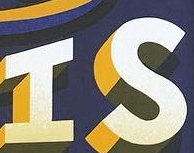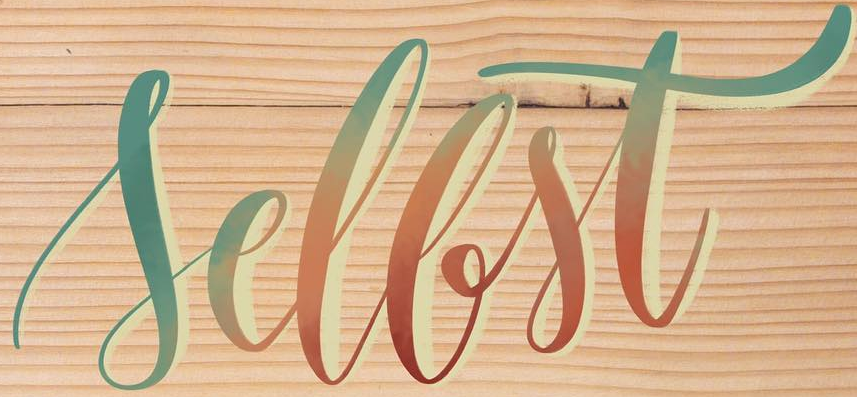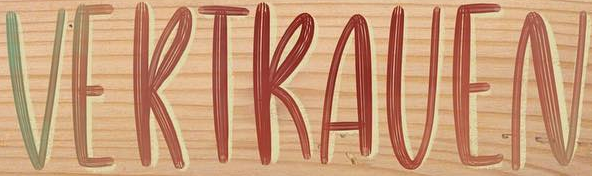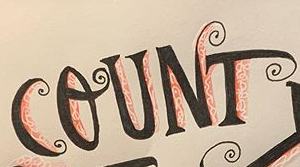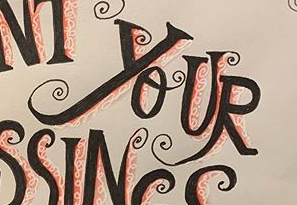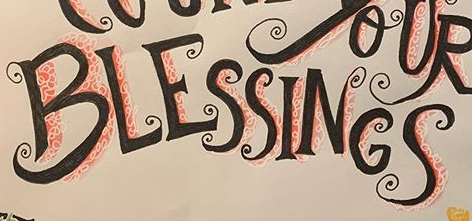What text is displayed in these images sequentially, separated by a semicolon? IS; Sellst; VERTRAVEN; COUNT; YOUR; BLESSINGS 